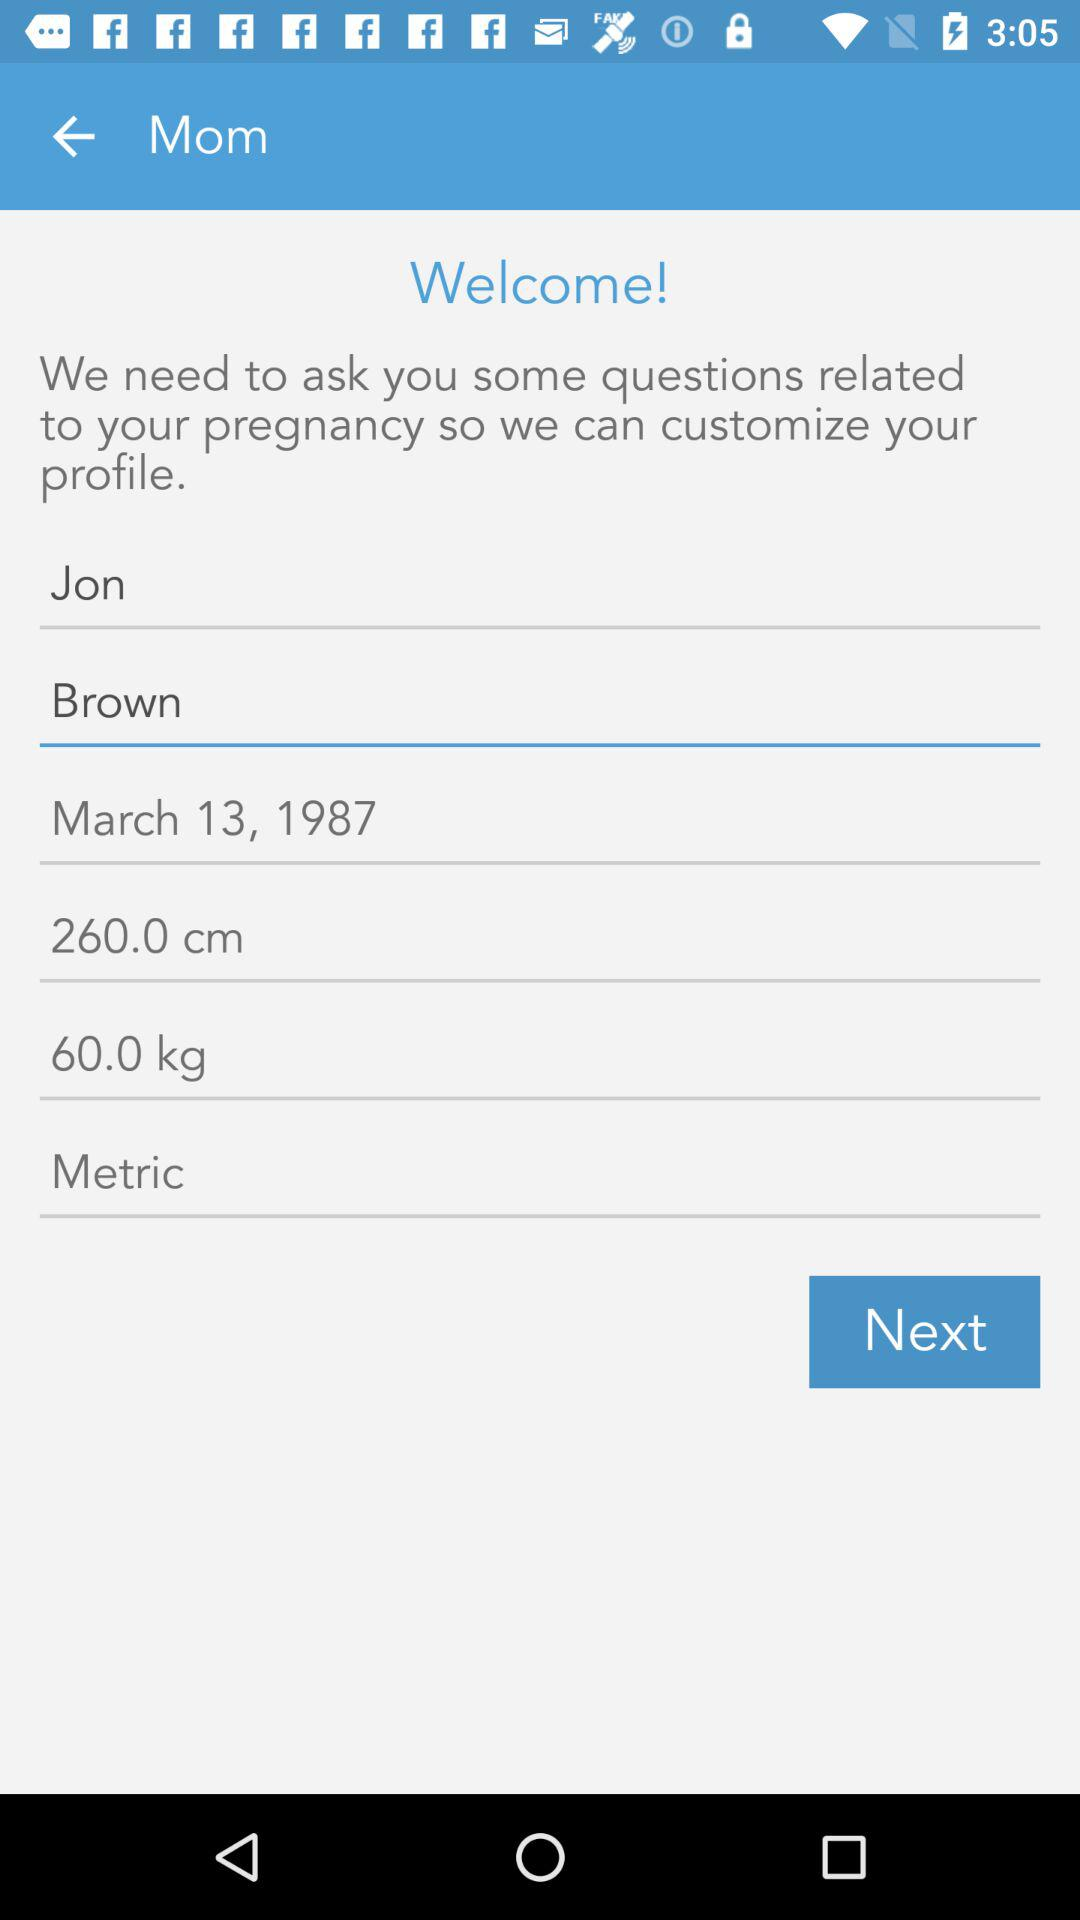What is the name of the person? The name of the person is Jon Brown. 